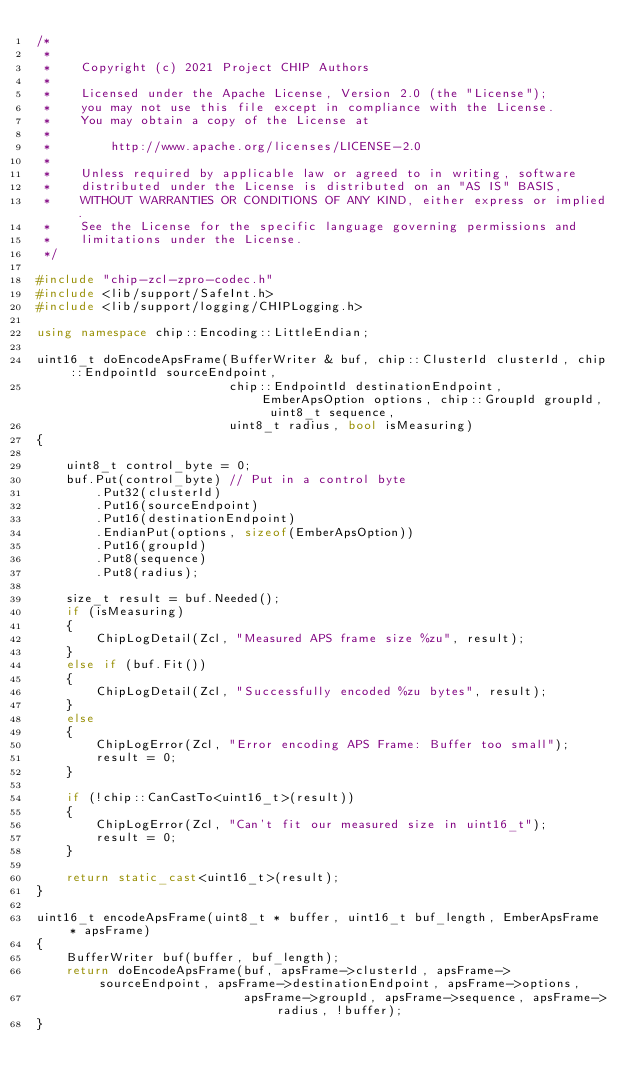Convert code to text. <code><loc_0><loc_0><loc_500><loc_500><_C++_>/*
 *
 *    Copyright (c) 2021 Project CHIP Authors
 *
 *    Licensed under the Apache License, Version 2.0 (the "License");
 *    you may not use this file except in compliance with the License.
 *    You may obtain a copy of the License at
 *
 *        http://www.apache.org/licenses/LICENSE-2.0
 *
 *    Unless required by applicable law or agreed to in writing, software
 *    distributed under the License is distributed on an "AS IS" BASIS,
 *    WITHOUT WARRANTIES OR CONDITIONS OF ANY KIND, either express or implied.
 *    See the License for the specific language governing permissions and
 *    limitations under the License.
 */

#include "chip-zcl-zpro-codec.h"
#include <lib/support/SafeInt.h>
#include <lib/support/logging/CHIPLogging.h>

using namespace chip::Encoding::LittleEndian;

uint16_t doEncodeApsFrame(BufferWriter & buf, chip::ClusterId clusterId, chip::EndpointId sourceEndpoint,
                          chip::EndpointId destinationEndpoint, EmberApsOption options, chip::GroupId groupId, uint8_t sequence,
                          uint8_t radius, bool isMeasuring)
{

    uint8_t control_byte = 0;
    buf.Put(control_byte) // Put in a control byte
        .Put32(clusterId)
        .Put16(sourceEndpoint)
        .Put16(destinationEndpoint)
        .EndianPut(options, sizeof(EmberApsOption))
        .Put16(groupId)
        .Put8(sequence)
        .Put8(radius);

    size_t result = buf.Needed();
    if (isMeasuring)
    {
        ChipLogDetail(Zcl, "Measured APS frame size %zu", result);
    }
    else if (buf.Fit())
    {
        ChipLogDetail(Zcl, "Successfully encoded %zu bytes", result);
    }
    else
    {
        ChipLogError(Zcl, "Error encoding APS Frame: Buffer too small");
        result = 0;
    }

    if (!chip::CanCastTo<uint16_t>(result))
    {
        ChipLogError(Zcl, "Can't fit our measured size in uint16_t");
        result = 0;
    }

    return static_cast<uint16_t>(result);
}

uint16_t encodeApsFrame(uint8_t * buffer, uint16_t buf_length, EmberApsFrame * apsFrame)
{
    BufferWriter buf(buffer, buf_length);
    return doEncodeApsFrame(buf, apsFrame->clusterId, apsFrame->sourceEndpoint, apsFrame->destinationEndpoint, apsFrame->options,
                            apsFrame->groupId, apsFrame->sequence, apsFrame->radius, !buffer);
}
</code> 